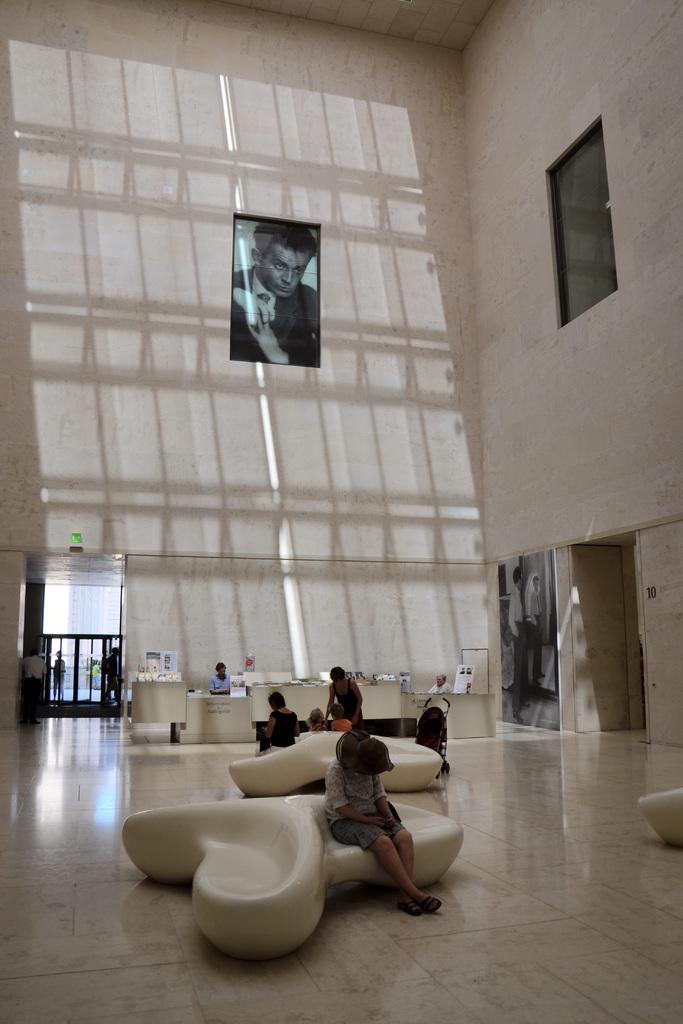In one or two sentences, can you explain what this image depicts? In this image there are some persons who are sitting on a couch, and in the center there is a reception and one person is sitting near the reception. And in the background there are some windows and one photo frame on the wall. On the right side there are some glass windows, photo frame and at the bottom there is floor. 